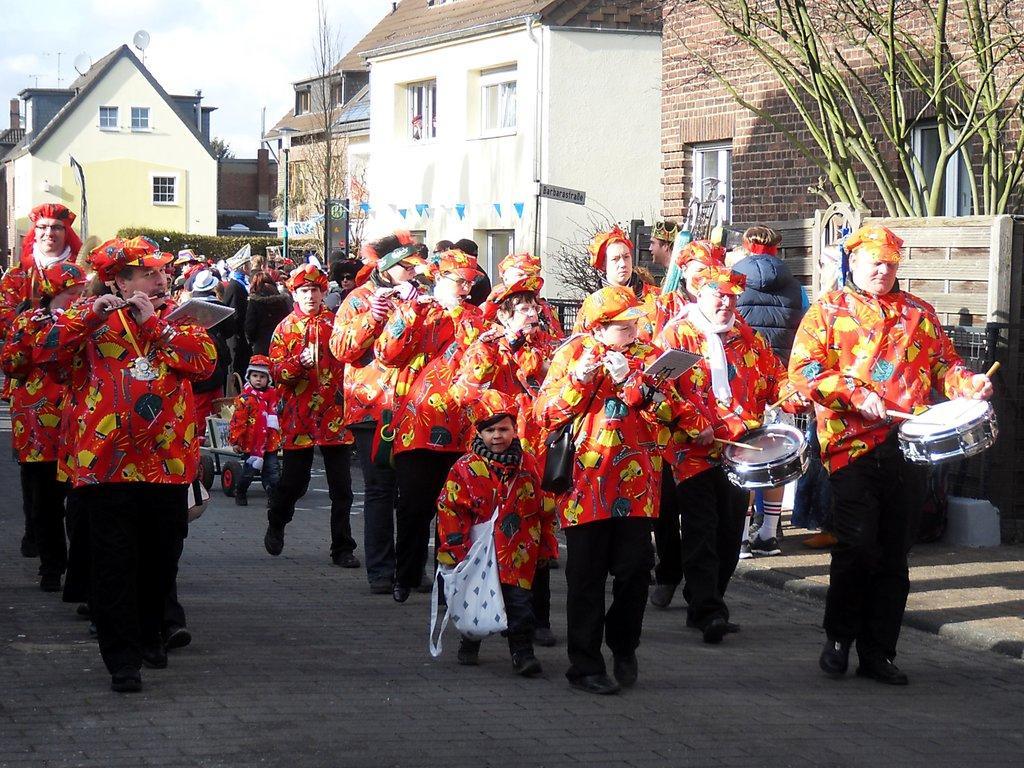How would you summarize this image in a sentence or two? In the picture we can see some a road on it, we can see some people are in a costume, they are playing musical instruments and walking and behind them, we can see a building with windows and near it we can see the poles, plants and in the background we can see a sky with clouds. 